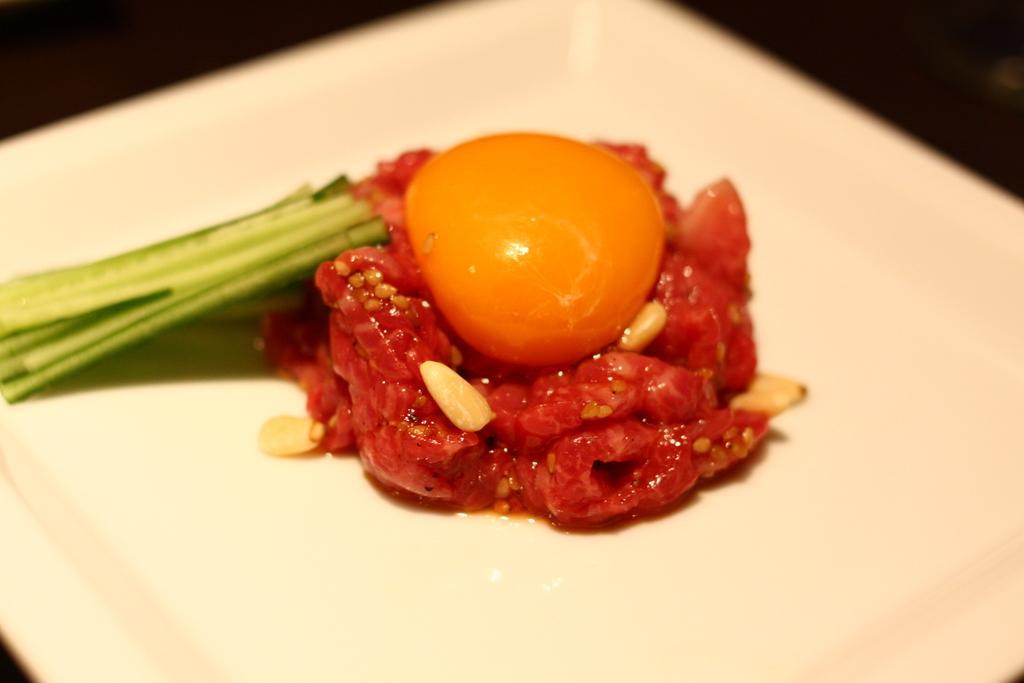Can you describe this image briefly? The picture consists of a food item served in a plate. At the top it is blurred. 